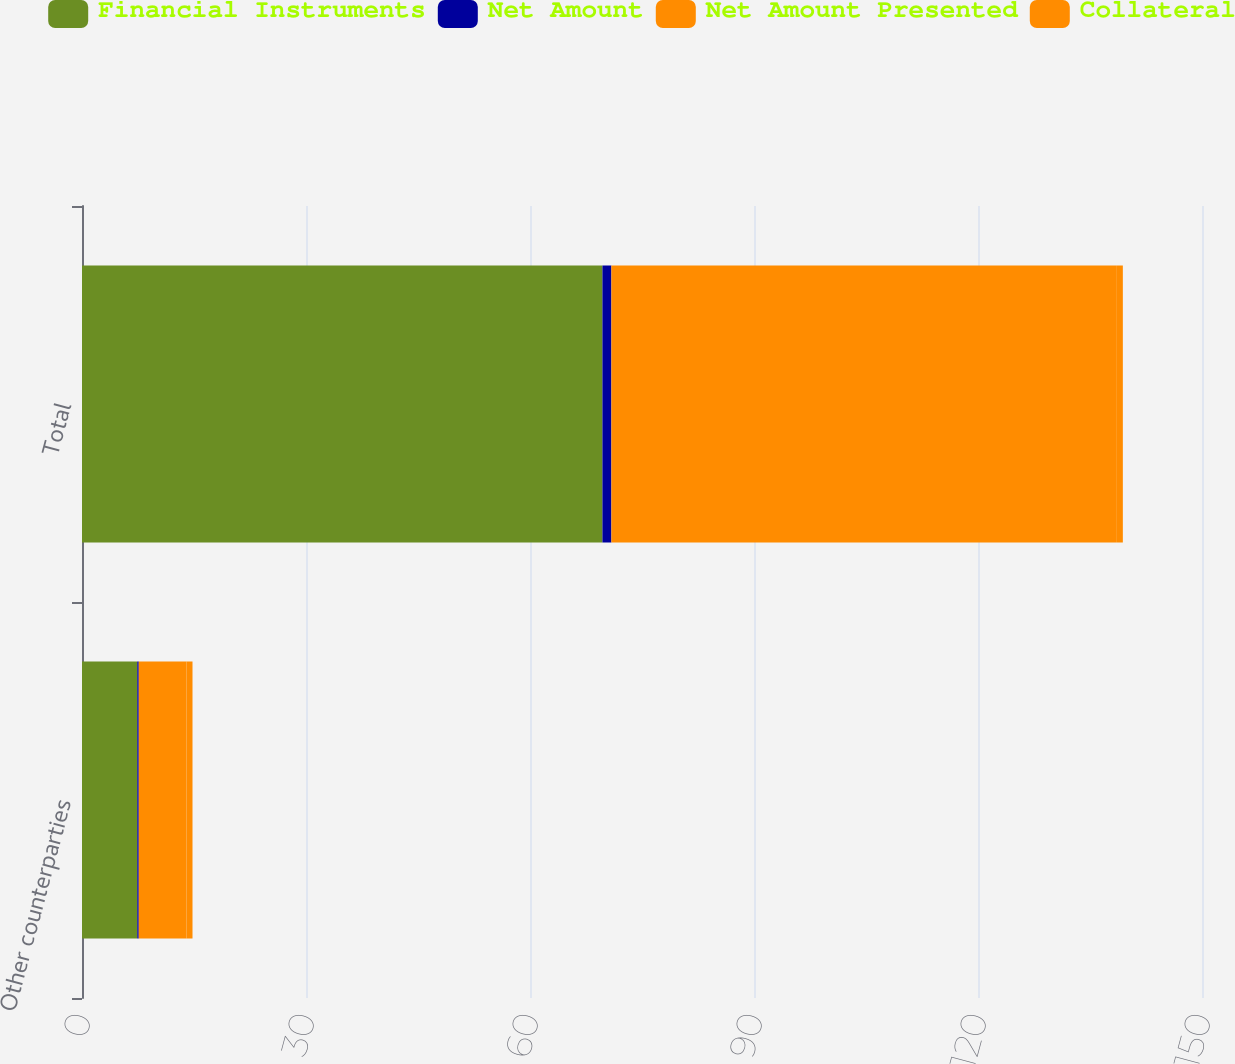Convert chart to OTSL. <chart><loc_0><loc_0><loc_500><loc_500><stacked_bar_chart><ecel><fcel>Other counterparties<fcel>Total<nl><fcel>Financial Instruments<fcel>7.4<fcel>69.7<nl><fcel>Net Amount<fcel>0.2<fcel>1.2<nl><fcel>Net Amount Presented<fcel>6.4<fcel>67.6<nl><fcel>Collateral<fcel>0.8<fcel>0.9<nl></chart> 